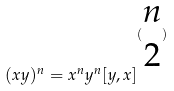<formula> <loc_0><loc_0><loc_500><loc_500>( x y ) ^ { n } = x ^ { n } y ^ { n } [ y , x ] ^ { ( \begin{matrix} n \\ 2 \end{matrix} ) }</formula> 